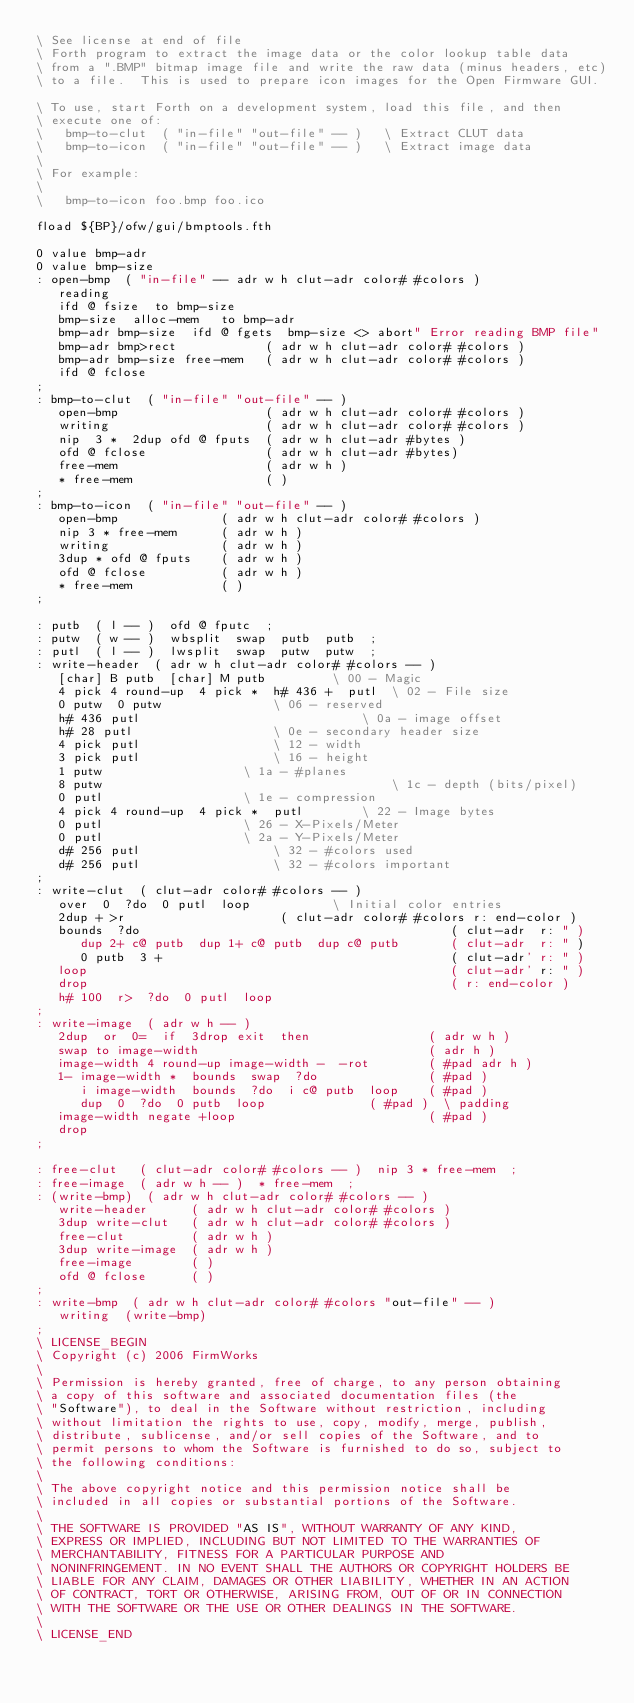<code> <loc_0><loc_0><loc_500><loc_500><_Forth_>\ See license at end of file
\ Forth program to extract the image data or the color lookup table data
\ from a ".BMP" bitmap image file and write the raw data (minus headers, etc)
\ to a file.  This is used to prepare icon images for the Open Firmware GUI.

\ To use, start Forth on a development system, load this file, and then
\ execute one of:
\   bmp-to-clut  ( "in-file" "out-file" -- )   \ Extract CLUT data
\   bmp-to-icon  ( "in-file" "out-file" -- )   \ Extract image data
\
\ For example:
\
\   bmp-to-icon foo.bmp foo.ico

fload ${BP}/ofw/gui/bmptools.fth

0 value bmp-adr
0 value bmp-size
: open-bmp  ( "in-file" -- adr w h clut-adr color# #colors )
   reading
   ifd @ fsize  to bmp-size
   bmp-size  alloc-mem   to bmp-adr
   bmp-adr bmp-size  ifd @ fgets  bmp-size <> abort" Error reading BMP file"
   bmp-adr bmp>rect            ( adr w h clut-adr color# #colors )
   bmp-adr bmp-size free-mem   ( adr w h clut-adr color# #colors )
   ifd @ fclose
;
: bmp-to-clut  ( "in-file" "out-file" -- )
   open-bmp                    ( adr w h clut-adr color# #colors )
   writing                     ( adr w h clut-adr color# #colors )
   nip  3 *  2dup ofd @ fputs  ( adr w h clut-adr #bytes )
   ofd @ fclose                ( adr w h clut-adr #bytes)
   free-mem                    ( adr w h )
   * free-mem                  ( )
;
: bmp-to-icon  ( "in-file" "out-file" -- )
   open-bmp              ( adr w h clut-adr color# #colors )
   nip 3 * free-mem      ( adr w h )
   writing               ( adr w h )
   3dup * ofd @ fputs    ( adr w h )
   ofd @ fclose          ( adr w h )
   * free-mem            ( )
;

: putb  ( l -- )  ofd @ fputc  ;
: putw  ( w -- )  wbsplit  swap  putb  putb  ;
: putl  ( l -- )  lwsplit  swap  putw  putw  ;
: write-header  ( adr w h clut-adr color# #colors -- )
   [char] B putb  [char] M putb			\ 00 - Magic
   4 pick 4 round-up  4 pick *  h# 436 +  putl	\ 02 - File size
   0 putw  0 putw				\ 06 - reserved
   h# 436 putl          	                \ 0a - image offset
   h# 28 putl					\ 0e - secondary header size
   4 pick putl					\ 12 - width
   3 pick putl					\ 16 - height
   1 putw					\ 1a - #planes
   8 putw                                       \ 1c - depth (bits/pixel)
   0 putl					\ 1e - compression
   4 pick 4 round-up  4 pick *  putl		\ 22 - Image bytes
   0 putl					\ 26 - X-Pixels/Meter
   0 putl					\ 2a - Y-Pixels/Meter
   d# 256 putl					\ 32 - #colors used
   d# 256 putl					\ 32 - #colors important
;
: write-clut  ( clut-adr color# #colors -- )
   over  0  ?do  0 putl  loop			\ Initial color entries
   2dup + >r                     ( clut-adr color# #colors r: end-color )
   bounds  ?do                                          ( clut-adr  r: " )
      dup 2+ c@ putb  dup 1+ c@ putb  dup c@ putb       ( clut-adr  r: " )
      0 putb  3 +                                       ( clut-adr' r: " )
   loop                                                 ( clut-adr' r: " )
   drop                                                 ( r: end-color )
   h# 100  r>  ?do  0 putl  loop
;
: write-image  ( adr w h -- )
   2dup  or  0=  if  3drop exit  then                ( adr w h )
   swap to image-width                               ( adr h )
   image-width 4 round-up image-width -  -rot        ( #pad adr h )
   1- image-width *  bounds  swap  ?do               ( #pad )
      i image-width  bounds  ?do  i c@ putb  loop    ( #pad )
      dup  0  ?do  0 putb  loop			     ( #pad )  \ padding
   image-width negate +loop                          ( #pad )
   drop
;

: free-clut   ( clut-adr color# #colors -- )  nip 3 * free-mem  ;
: free-image  ( adr w h -- )  * free-mem  ;
: (write-bmp)  ( adr w h clut-adr color# #colors -- )
   write-header      ( adr w h clut-adr color# #colors )
   3dup write-clut   ( adr w h clut-adr color# #colors )
   free-clut         ( adr w h )
   3dup write-image  ( adr w h )
   free-image        ( )
   ofd @ fclose      ( )
;
: write-bmp  ( adr w h clut-adr color# #colors "out-file" -- )
   writing  (write-bmp)
;
\ LICENSE_BEGIN
\ Copyright (c) 2006 FirmWorks
\ 
\ Permission is hereby granted, free of charge, to any person obtaining
\ a copy of this software and associated documentation files (the
\ "Software"), to deal in the Software without restriction, including
\ without limitation the rights to use, copy, modify, merge, publish,
\ distribute, sublicense, and/or sell copies of the Software, and to
\ permit persons to whom the Software is furnished to do so, subject to
\ the following conditions:
\ 
\ The above copyright notice and this permission notice shall be
\ included in all copies or substantial portions of the Software.
\ 
\ THE SOFTWARE IS PROVIDED "AS IS", WITHOUT WARRANTY OF ANY KIND,
\ EXPRESS OR IMPLIED, INCLUDING BUT NOT LIMITED TO THE WARRANTIES OF
\ MERCHANTABILITY, FITNESS FOR A PARTICULAR PURPOSE AND
\ NONINFRINGEMENT. IN NO EVENT SHALL THE AUTHORS OR COPYRIGHT HOLDERS BE
\ LIABLE FOR ANY CLAIM, DAMAGES OR OTHER LIABILITY, WHETHER IN AN ACTION
\ OF CONTRACT, TORT OR OTHERWISE, ARISING FROM, OUT OF OR IN CONNECTION
\ WITH THE SOFTWARE OR THE USE OR OTHER DEALINGS IN THE SOFTWARE.
\
\ LICENSE_END
</code> 